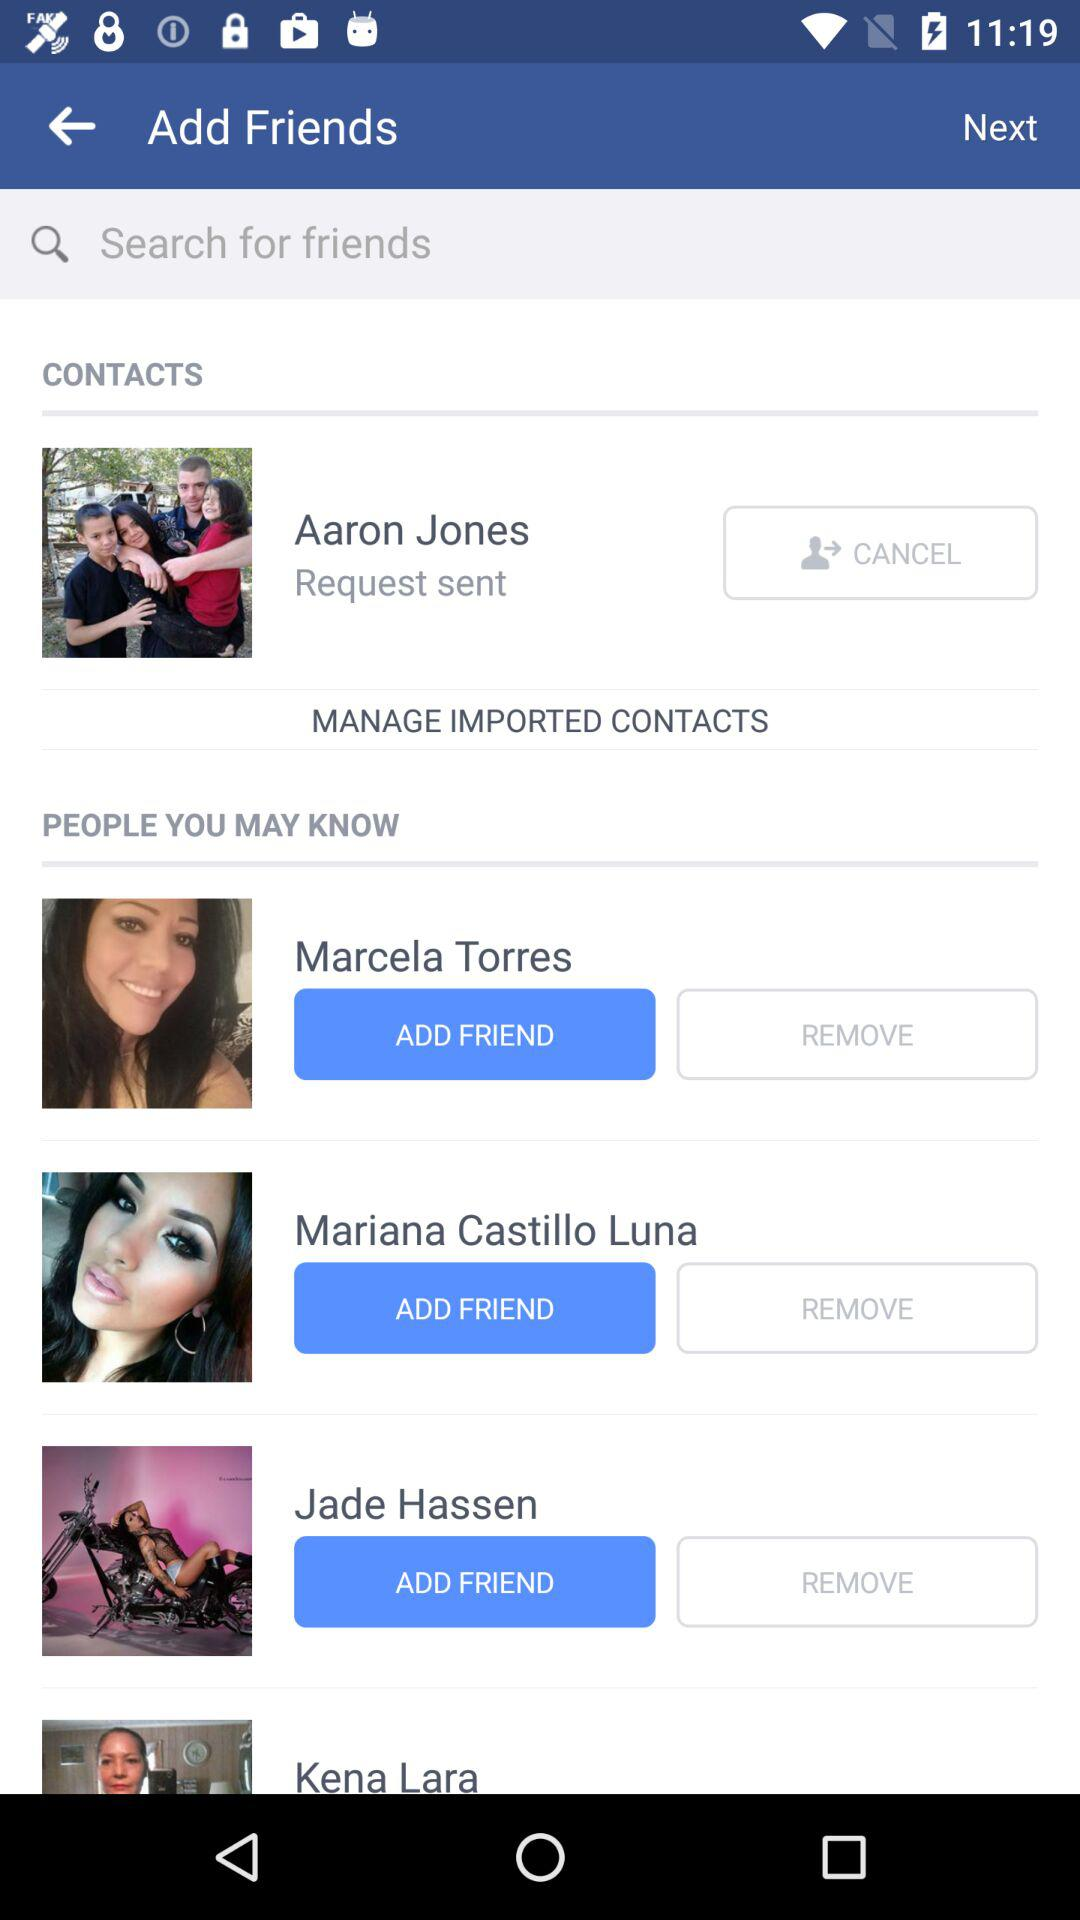How many people have you sent a friend request to?
Answer the question using a single word or phrase. 1 